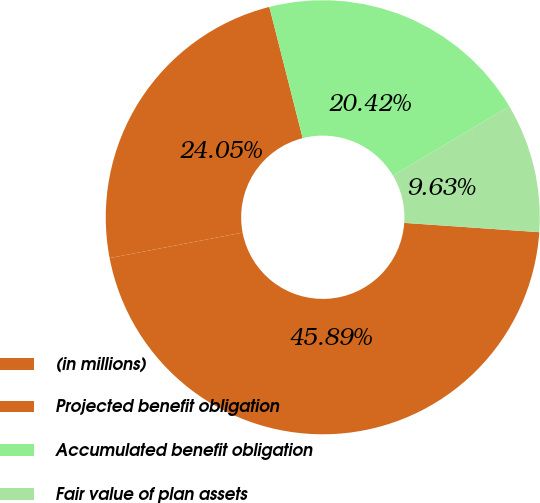Convert chart to OTSL. <chart><loc_0><loc_0><loc_500><loc_500><pie_chart><fcel>(in millions)<fcel>Projected benefit obligation<fcel>Accumulated benefit obligation<fcel>Fair value of plan assets<nl><fcel>45.89%<fcel>24.05%<fcel>20.42%<fcel>9.63%<nl></chart> 